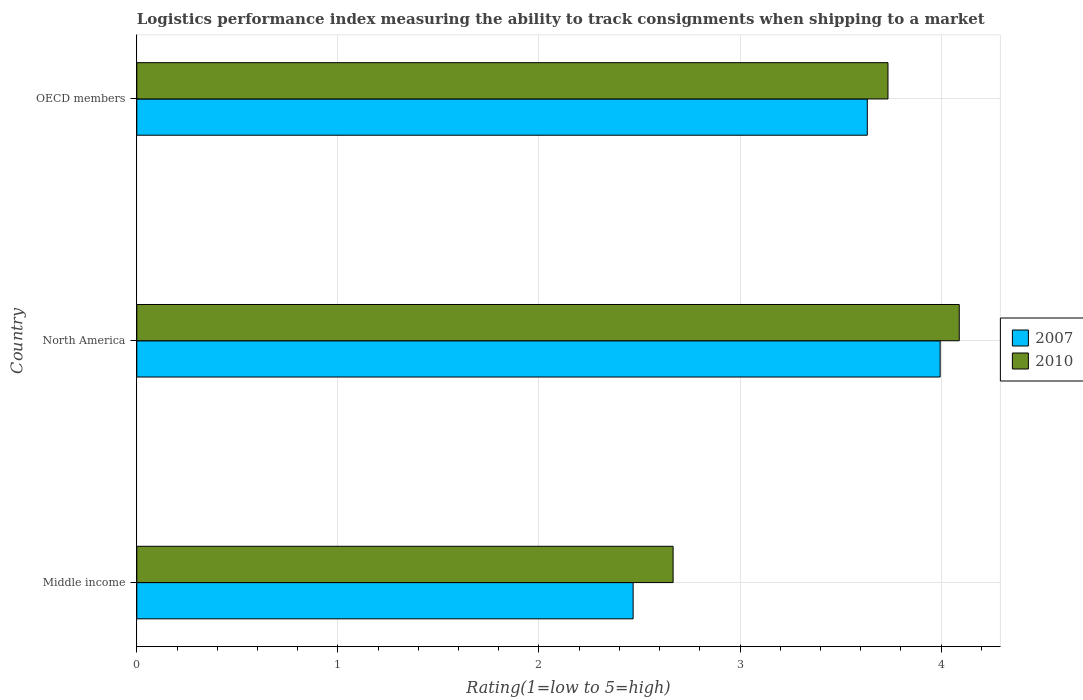How many groups of bars are there?
Offer a very short reply. 3. Are the number of bars per tick equal to the number of legend labels?
Your answer should be very brief. Yes. Are the number of bars on each tick of the Y-axis equal?
Make the answer very short. Yes. How many bars are there on the 2nd tick from the bottom?
Provide a short and direct response. 2. In how many cases, is the number of bars for a given country not equal to the number of legend labels?
Make the answer very short. 0. What is the Logistic performance index in 2010 in OECD members?
Ensure brevity in your answer.  3.74. Across all countries, what is the maximum Logistic performance index in 2007?
Make the answer very short. 4. Across all countries, what is the minimum Logistic performance index in 2010?
Offer a very short reply. 2.67. In which country was the Logistic performance index in 2007 maximum?
Offer a very short reply. North America. In which country was the Logistic performance index in 2010 minimum?
Your answer should be compact. Middle income. What is the total Logistic performance index in 2007 in the graph?
Your answer should be very brief. 10.1. What is the difference between the Logistic performance index in 2007 in North America and that in OECD members?
Your answer should be compact. 0.36. What is the difference between the Logistic performance index in 2007 in Middle income and the Logistic performance index in 2010 in North America?
Your response must be concise. -1.62. What is the average Logistic performance index in 2007 per country?
Keep it short and to the point. 3.37. What is the difference between the Logistic performance index in 2007 and Logistic performance index in 2010 in North America?
Your response must be concise. -0.09. What is the ratio of the Logistic performance index in 2010 in Middle income to that in North America?
Keep it short and to the point. 0.65. Is the Logistic performance index in 2010 in Middle income less than that in OECD members?
Provide a short and direct response. Yes. Is the difference between the Logistic performance index in 2007 in Middle income and North America greater than the difference between the Logistic performance index in 2010 in Middle income and North America?
Your response must be concise. No. What is the difference between the highest and the second highest Logistic performance index in 2007?
Provide a succinct answer. 0.36. What is the difference between the highest and the lowest Logistic performance index in 2010?
Provide a short and direct response. 1.42. In how many countries, is the Logistic performance index in 2010 greater than the average Logistic performance index in 2010 taken over all countries?
Your response must be concise. 2. Is the sum of the Logistic performance index in 2007 in Middle income and OECD members greater than the maximum Logistic performance index in 2010 across all countries?
Provide a succinct answer. Yes. What does the 2nd bar from the bottom in North America represents?
Your answer should be very brief. 2010. How many bars are there?
Your answer should be compact. 6. What is the difference between two consecutive major ticks on the X-axis?
Provide a succinct answer. 1. Are the values on the major ticks of X-axis written in scientific E-notation?
Ensure brevity in your answer.  No. Does the graph contain grids?
Provide a short and direct response. Yes. Where does the legend appear in the graph?
Your answer should be very brief. Center right. How many legend labels are there?
Ensure brevity in your answer.  2. What is the title of the graph?
Make the answer very short. Logistics performance index measuring the ability to track consignments when shipping to a market. What is the label or title of the X-axis?
Offer a terse response. Rating(1=low to 5=high). What is the label or title of the Y-axis?
Offer a very short reply. Country. What is the Rating(1=low to 5=high) of 2007 in Middle income?
Keep it short and to the point. 2.47. What is the Rating(1=low to 5=high) of 2010 in Middle income?
Your answer should be compact. 2.67. What is the Rating(1=low to 5=high) in 2007 in North America?
Offer a terse response. 4. What is the Rating(1=low to 5=high) of 2010 in North America?
Provide a short and direct response. 4.09. What is the Rating(1=low to 5=high) in 2007 in OECD members?
Give a very brief answer. 3.63. What is the Rating(1=low to 5=high) of 2010 in OECD members?
Give a very brief answer. 3.74. Across all countries, what is the maximum Rating(1=low to 5=high) in 2007?
Provide a short and direct response. 4. Across all countries, what is the maximum Rating(1=low to 5=high) of 2010?
Offer a terse response. 4.09. Across all countries, what is the minimum Rating(1=low to 5=high) in 2007?
Keep it short and to the point. 2.47. Across all countries, what is the minimum Rating(1=low to 5=high) in 2010?
Give a very brief answer. 2.67. What is the total Rating(1=low to 5=high) in 2007 in the graph?
Your answer should be very brief. 10.1. What is the total Rating(1=low to 5=high) in 2010 in the graph?
Give a very brief answer. 10.49. What is the difference between the Rating(1=low to 5=high) of 2007 in Middle income and that in North America?
Provide a short and direct response. -1.53. What is the difference between the Rating(1=low to 5=high) in 2010 in Middle income and that in North America?
Your answer should be very brief. -1.42. What is the difference between the Rating(1=low to 5=high) of 2007 in Middle income and that in OECD members?
Offer a very short reply. -1.16. What is the difference between the Rating(1=low to 5=high) of 2010 in Middle income and that in OECD members?
Keep it short and to the point. -1.07. What is the difference between the Rating(1=low to 5=high) of 2007 in North America and that in OECD members?
Offer a very short reply. 0.36. What is the difference between the Rating(1=low to 5=high) of 2010 in North America and that in OECD members?
Offer a terse response. 0.35. What is the difference between the Rating(1=low to 5=high) of 2007 in Middle income and the Rating(1=low to 5=high) of 2010 in North America?
Ensure brevity in your answer.  -1.62. What is the difference between the Rating(1=low to 5=high) of 2007 in Middle income and the Rating(1=low to 5=high) of 2010 in OECD members?
Keep it short and to the point. -1.27. What is the difference between the Rating(1=low to 5=high) of 2007 in North America and the Rating(1=low to 5=high) of 2010 in OECD members?
Provide a succinct answer. 0.26. What is the average Rating(1=low to 5=high) in 2007 per country?
Keep it short and to the point. 3.37. What is the average Rating(1=low to 5=high) in 2010 per country?
Your answer should be very brief. 3.5. What is the difference between the Rating(1=low to 5=high) in 2007 and Rating(1=low to 5=high) in 2010 in Middle income?
Your answer should be very brief. -0.2. What is the difference between the Rating(1=low to 5=high) in 2007 and Rating(1=low to 5=high) in 2010 in North America?
Offer a terse response. -0.1. What is the difference between the Rating(1=low to 5=high) of 2007 and Rating(1=low to 5=high) of 2010 in OECD members?
Your response must be concise. -0.1. What is the ratio of the Rating(1=low to 5=high) of 2007 in Middle income to that in North America?
Offer a terse response. 0.62. What is the ratio of the Rating(1=low to 5=high) in 2010 in Middle income to that in North America?
Keep it short and to the point. 0.65. What is the ratio of the Rating(1=low to 5=high) of 2007 in Middle income to that in OECD members?
Make the answer very short. 0.68. What is the ratio of the Rating(1=low to 5=high) of 2010 in Middle income to that in OECD members?
Provide a short and direct response. 0.71. What is the ratio of the Rating(1=low to 5=high) of 2007 in North America to that in OECD members?
Offer a terse response. 1.1. What is the ratio of the Rating(1=low to 5=high) of 2010 in North America to that in OECD members?
Keep it short and to the point. 1.09. What is the difference between the highest and the second highest Rating(1=low to 5=high) in 2007?
Give a very brief answer. 0.36. What is the difference between the highest and the second highest Rating(1=low to 5=high) in 2010?
Your response must be concise. 0.35. What is the difference between the highest and the lowest Rating(1=low to 5=high) of 2007?
Ensure brevity in your answer.  1.53. What is the difference between the highest and the lowest Rating(1=low to 5=high) in 2010?
Your response must be concise. 1.42. 